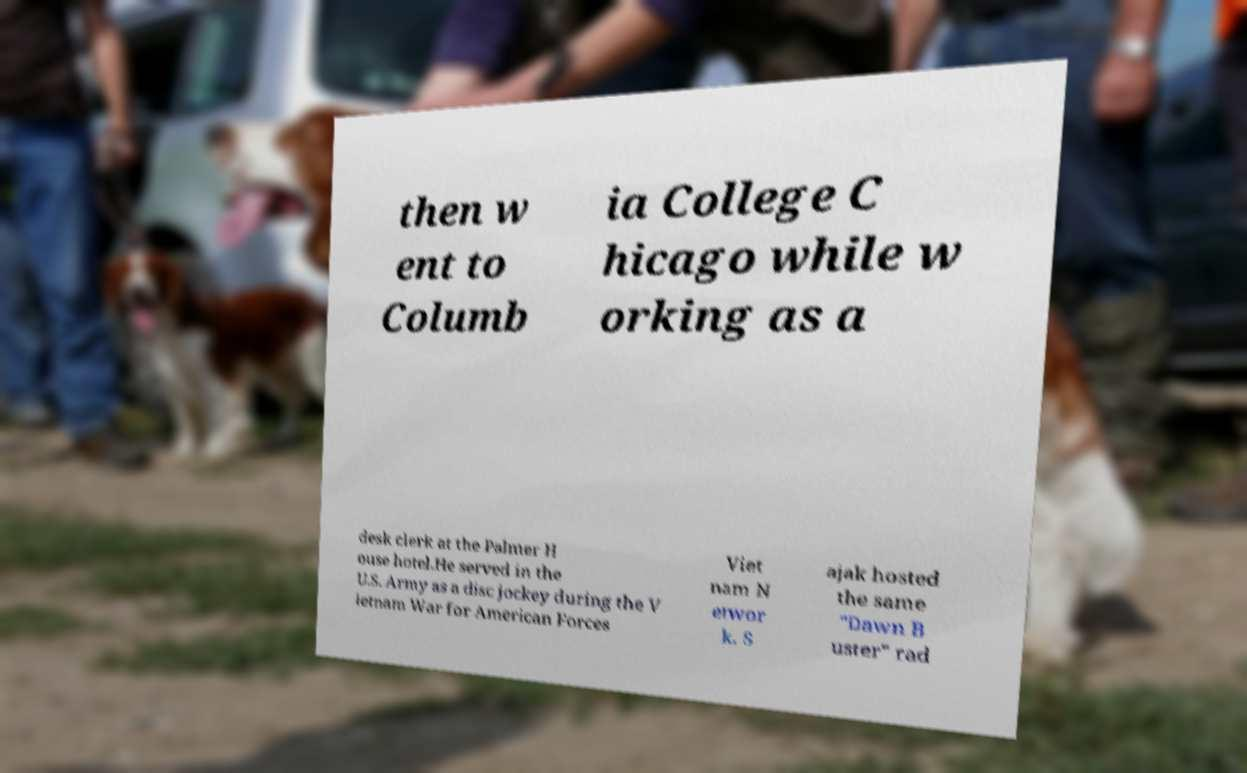I need the written content from this picture converted into text. Can you do that? then w ent to Columb ia College C hicago while w orking as a desk clerk at the Palmer H ouse hotel.He served in the U.S. Army as a disc jockey during the V ietnam War for American Forces Viet nam N etwor k. S ajak hosted the same "Dawn B uster" rad 